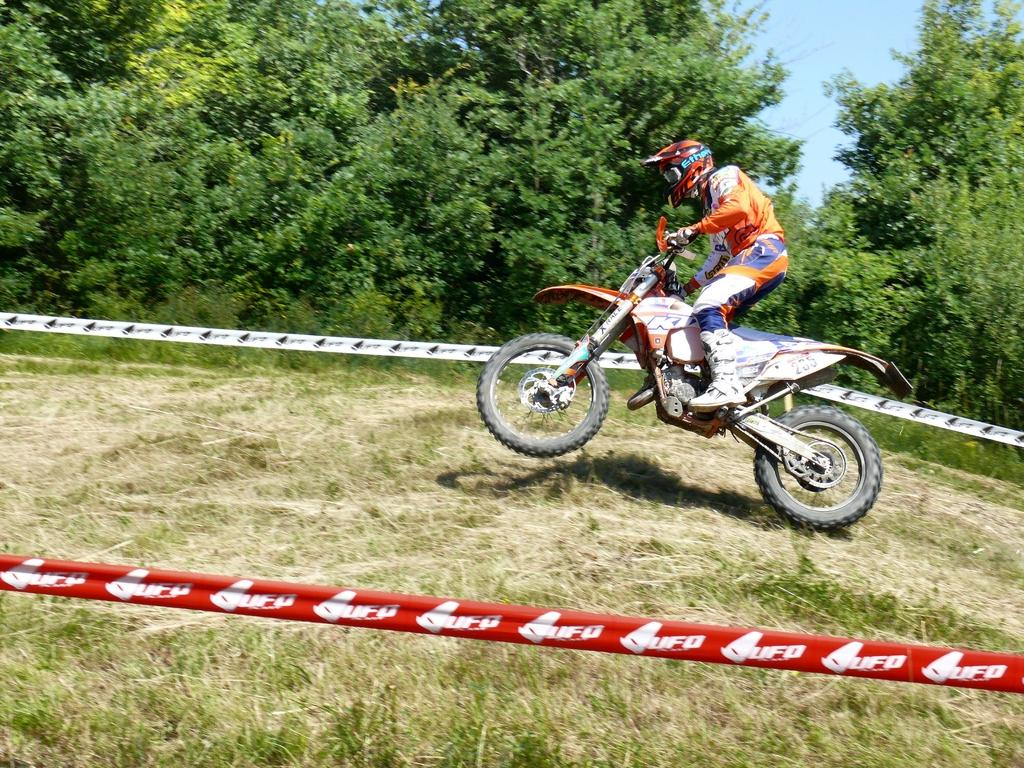What is the person in the image doing? The person is riding a bike in the image. What safety precaution is the person taking? The person is wearing a helmet. What is the purpose of the caution tape around the person? The caution tape around the person may indicate that they are participating in an event or activity that requires caution or safety measures. What can be seen in the background of the image? The sky, trees, and grass are visible in the background of the image. What type of mist is covering the person's legs in the image? There is no mist present in the image, and the person's legs are not covered. 